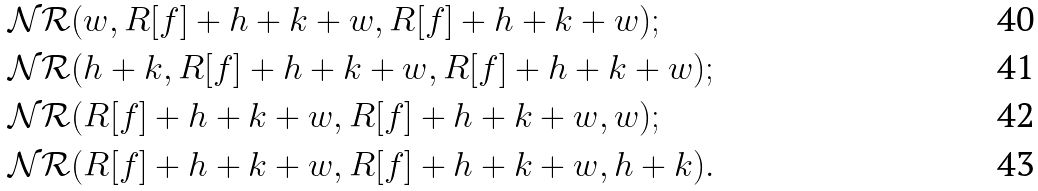Convert formula to latex. <formula><loc_0><loc_0><loc_500><loc_500>& \mathcal { N R } ( w , R [ f ] + h + k + w , R [ f ] + h + k + w ) ; \\ & \mathcal { N R } ( h + k , R [ f ] + h + k + w , R [ f ] + h + k + w ) ; \\ & \mathcal { N R } ( R [ f ] + h + k + w , R [ f ] + h + k + w , w ) ; \\ & \mathcal { N R } ( R [ f ] + h + k + w , R [ f ] + h + k + w , h + k ) .</formula> 